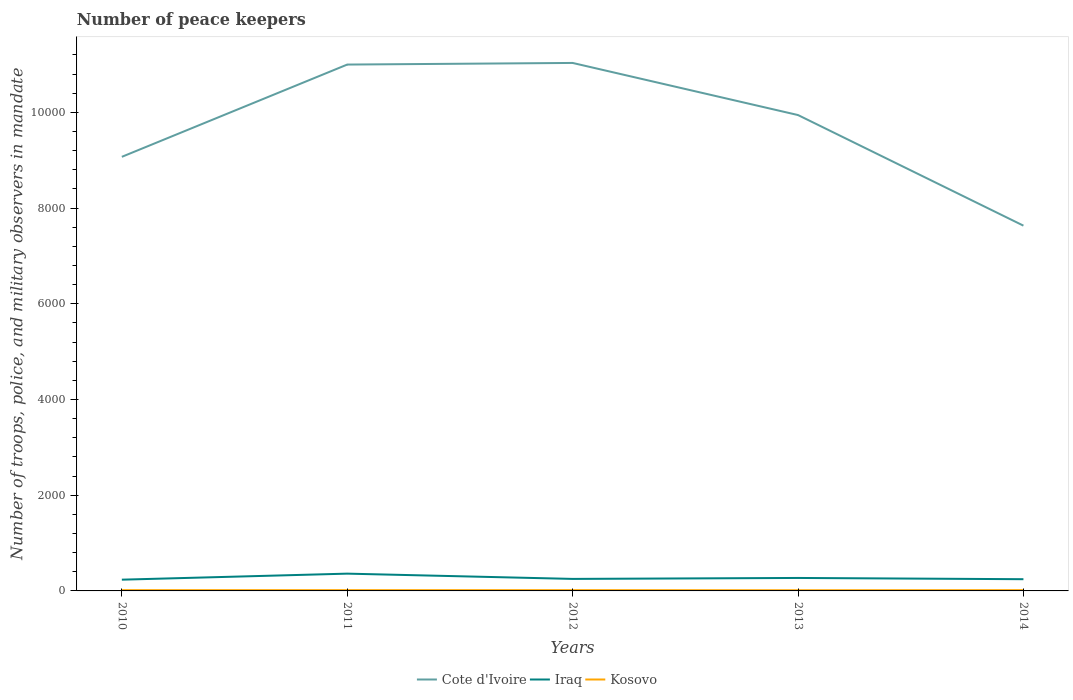How many different coloured lines are there?
Your response must be concise. 3. Across all years, what is the maximum number of peace keepers in in Iraq?
Your answer should be compact. 235. In which year was the number of peace keepers in in Kosovo maximum?
Your response must be concise. 2013. What is the total number of peace keepers in in Iraq in the graph?
Offer a terse response. -20. What is the difference between the highest and the second highest number of peace keepers in in Cote d'Ivoire?
Ensure brevity in your answer.  3400. What is the difference between the highest and the lowest number of peace keepers in in Cote d'Ivoire?
Keep it short and to the point. 3. Is the number of peace keepers in in Iraq strictly greater than the number of peace keepers in in Kosovo over the years?
Provide a short and direct response. No. How many lines are there?
Give a very brief answer. 3. Are the values on the major ticks of Y-axis written in scientific E-notation?
Give a very brief answer. No. Does the graph contain grids?
Keep it short and to the point. No. How are the legend labels stacked?
Provide a short and direct response. Horizontal. What is the title of the graph?
Your answer should be compact. Number of peace keepers. Does "Suriname" appear as one of the legend labels in the graph?
Offer a very short reply. No. What is the label or title of the X-axis?
Your response must be concise. Years. What is the label or title of the Y-axis?
Give a very brief answer. Number of troops, police, and military observers in mandate. What is the Number of troops, police, and military observers in mandate of Cote d'Ivoire in 2010?
Ensure brevity in your answer.  9071. What is the Number of troops, police, and military observers in mandate of Iraq in 2010?
Offer a terse response. 235. What is the Number of troops, police, and military observers in mandate of Kosovo in 2010?
Your answer should be very brief. 16. What is the Number of troops, police, and military observers in mandate in Cote d'Ivoire in 2011?
Your answer should be very brief. 1.10e+04. What is the Number of troops, police, and military observers in mandate of Iraq in 2011?
Your answer should be very brief. 361. What is the Number of troops, police, and military observers in mandate in Cote d'Ivoire in 2012?
Make the answer very short. 1.10e+04. What is the Number of troops, police, and military observers in mandate in Iraq in 2012?
Make the answer very short. 251. What is the Number of troops, police, and military observers in mandate in Cote d'Ivoire in 2013?
Keep it short and to the point. 9944. What is the Number of troops, police, and military observers in mandate in Iraq in 2013?
Give a very brief answer. 271. What is the Number of troops, police, and military observers in mandate of Kosovo in 2013?
Keep it short and to the point. 14. What is the Number of troops, police, and military observers in mandate in Cote d'Ivoire in 2014?
Your response must be concise. 7633. What is the Number of troops, police, and military observers in mandate of Iraq in 2014?
Make the answer very short. 245. What is the Number of troops, police, and military observers in mandate in Kosovo in 2014?
Offer a very short reply. 16. Across all years, what is the maximum Number of troops, police, and military observers in mandate of Cote d'Ivoire?
Your answer should be very brief. 1.10e+04. Across all years, what is the maximum Number of troops, police, and military observers in mandate in Iraq?
Your answer should be compact. 361. Across all years, what is the maximum Number of troops, police, and military observers in mandate of Kosovo?
Give a very brief answer. 16. Across all years, what is the minimum Number of troops, police, and military observers in mandate of Cote d'Ivoire?
Give a very brief answer. 7633. Across all years, what is the minimum Number of troops, police, and military observers in mandate in Iraq?
Give a very brief answer. 235. What is the total Number of troops, police, and military observers in mandate in Cote d'Ivoire in the graph?
Provide a succinct answer. 4.87e+04. What is the total Number of troops, police, and military observers in mandate of Iraq in the graph?
Provide a short and direct response. 1363. What is the difference between the Number of troops, police, and military observers in mandate of Cote d'Ivoire in 2010 and that in 2011?
Offer a terse response. -1928. What is the difference between the Number of troops, police, and military observers in mandate of Iraq in 2010 and that in 2011?
Keep it short and to the point. -126. What is the difference between the Number of troops, police, and military observers in mandate of Kosovo in 2010 and that in 2011?
Your response must be concise. 0. What is the difference between the Number of troops, police, and military observers in mandate of Cote d'Ivoire in 2010 and that in 2012?
Ensure brevity in your answer.  -1962. What is the difference between the Number of troops, police, and military observers in mandate in Kosovo in 2010 and that in 2012?
Offer a terse response. 0. What is the difference between the Number of troops, police, and military observers in mandate in Cote d'Ivoire in 2010 and that in 2013?
Your answer should be very brief. -873. What is the difference between the Number of troops, police, and military observers in mandate of Iraq in 2010 and that in 2013?
Your response must be concise. -36. What is the difference between the Number of troops, police, and military observers in mandate in Kosovo in 2010 and that in 2013?
Offer a very short reply. 2. What is the difference between the Number of troops, police, and military observers in mandate of Cote d'Ivoire in 2010 and that in 2014?
Your answer should be compact. 1438. What is the difference between the Number of troops, police, and military observers in mandate of Cote d'Ivoire in 2011 and that in 2012?
Make the answer very short. -34. What is the difference between the Number of troops, police, and military observers in mandate of Iraq in 2011 and that in 2012?
Provide a succinct answer. 110. What is the difference between the Number of troops, police, and military observers in mandate in Cote d'Ivoire in 2011 and that in 2013?
Provide a succinct answer. 1055. What is the difference between the Number of troops, police, and military observers in mandate of Cote d'Ivoire in 2011 and that in 2014?
Provide a succinct answer. 3366. What is the difference between the Number of troops, police, and military observers in mandate of Iraq in 2011 and that in 2014?
Your answer should be compact. 116. What is the difference between the Number of troops, police, and military observers in mandate of Cote d'Ivoire in 2012 and that in 2013?
Make the answer very short. 1089. What is the difference between the Number of troops, police, and military observers in mandate of Iraq in 2012 and that in 2013?
Give a very brief answer. -20. What is the difference between the Number of troops, police, and military observers in mandate of Cote d'Ivoire in 2012 and that in 2014?
Ensure brevity in your answer.  3400. What is the difference between the Number of troops, police, and military observers in mandate of Cote d'Ivoire in 2013 and that in 2014?
Your answer should be very brief. 2311. What is the difference between the Number of troops, police, and military observers in mandate of Iraq in 2013 and that in 2014?
Your answer should be compact. 26. What is the difference between the Number of troops, police, and military observers in mandate in Kosovo in 2013 and that in 2014?
Offer a very short reply. -2. What is the difference between the Number of troops, police, and military observers in mandate of Cote d'Ivoire in 2010 and the Number of troops, police, and military observers in mandate of Iraq in 2011?
Offer a very short reply. 8710. What is the difference between the Number of troops, police, and military observers in mandate in Cote d'Ivoire in 2010 and the Number of troops, police, and military observers in mandate in Kosovo in 2011?
Your answer should be compact. 9055. What is the difference between the Number of troops, police, and military observers in mandate of Iraq in 2010 and the Number of troops, police, and military observers in mandate of Kosovo in 2011?
Your answer should be compact. 219. What is the difference between the Number of troops, police, and military observers in mandate in Cote d'Ivoire in 2010 and the Number of troops, police, and military observers in mandate in Iraq in 2012?
Give a very brief answer. 8820. What is the difference between the Number of troops, police, and military observers in mandate of Cote d'Ivoire in 2010 and the Number of troops, police, and military observers in mandate of Kosovo in 2012?
Offer a very short reply. 9055. What is the difference between the Number of troops, police, and military observers in mandate in Iraq in 2010 and the Number of troops, police, and military observers in mandate in Kosovo in 2012?
Your response must be concise. 219. What is the difference between the Number of troops, police, and military observers in mandate of Cote d'Ivoire in 2010 and the Number of troops, police, and military observers in mandate of Iraq in 2013?
Offer a very short reply. 8800. What is the difference between the Number of troops, police, and military observers in mandate of Cote d'Ivoire in 2010 and the Number of troops, police, and military observers in mandate of Kosovo in 2013?
Ensure brevity in your answer.  9057. What is the difference between the Number of troops, police, and military observers in mandate in Iraq in 2010 and the Number of troops, police, and military observers in mandate in Kosovo in 2013?
Keep it short and to the point. 221. What is the difference between the Number of troops, police, and military observers in mandate in Cote d'Ivoire in 2010 and the Number of troops, police, and military observers in mandate in Iraq in 2014?
Offer a terse response. 8826. What is the difference between the Number of troops, police, and military observers in mandate of Cote d'Ivoire in 2010 and the Number of troops, police, and military observers in mandate of Kosovo in 2014?
Your answer should be compact. 9055. What is the difference between the Number of troops, police, and military observers in mandate in Iraq in 2010 and the Number of troops, police, and military observers in mandate in Kosovo in 2014?
Offer a very short reply. 219. What is the difference between the Number of troops, police, and military observers in mandate in Cote d'Ivoire in 2011 and the Number of troops, police, and military observers in mandate in Iraq in 2012?
Provide a short and direct response. 1.07e+04. What is the difference between the Number of troops, police, and military observers in mandate of Cote d'Ivoire in 2011 and the Number of troops, police, and military observers in mandate of Kosovo in 2012?
Give a very brief answer. 1.10e+04. What is the difference between the Number of troops, police, and military observers in mandate in Iraq in 2011 and the Number of troops, police, and military observers in mandate in Kosovo in 2012?
Ensure brevity in your answer.  345. What is the difference between the Number of troops, police, and military observers in mandate of Cote d'Ivoire in 2011 and the Number of troops, police, and military observers in mandate of Iraq in 2013?
Offer a terse response. 1.07e+04. What is the difference between the Number of troops, police, and military observers in mandate in Cote d'Ivoire in 2011 and the Number of troops, police, and military observers in mandate in Kosovo in 2013?
Provide a short and direct response. 1.10e+04. What is the difference between the Number of troops, police, and military observers in mandate in Iraq in 2011 and the Number of troops, police, and military observers in mandate in Kosovo in 2013?
Make the answer very short. 347. What is the difference between the Number of troops, police, and military observers in mandate of Cote d'Ivoire in 2011 and the Number of troops, police, and military observers in mandate of Iraq in 2014?
Give a very brief answer. 1.08e+04. What is the difference between the Number of troops, police, and military observers in mandate of Cote d'Ivoire in 2011 and the Number of troops, police, and military observers in mandate of Kosovo in 2014?
Your answer should be compact. 1.10e+04. What is the difference between the Number of troops, police, and military observers in mandate of Iraq in 2011 and the Number of troops, police, and military observers in mandate of Kosovo in 2014?
Provide a succinct answer. 345. What is the difference between the Number of troops, police, and military observers in mandate in Cote d'Ivoire in 2012 and the Number of troops, police, and military observers in mandate in Iraq in 2013?
Keep it short and to the point. 1.08e+04. What is the difference between the Number of troops, police, and military observers in mandate of Cote d'Ivoire in 2012 and the Number of troops, police, and military observers in mandate of Kosovo in 2013?
Your answer should be compact. 1.10e+04. What is the difference between the Number of troops, police, and military observers in mandate in Iraq in 2012 and the Number of troops, police, and military observers in mandate in Kosovo in 2013?
Your answer should be compact. 237. What is the difference between the Number of troops, police, and military observers in mandate of Cote d'Ivoire in 2012 and the Number of troops, police, and military observers in mandate of Iraq in 2014?
Offer a very short reply. 1.08e+04. What is the difference between the Number of troops, police, and military observers in mandate of Cote d'Ivoire in 2012 and the Number of troops, police, and military observers in mandate of Kosovo in 2014?
Give a very brief answer. 1.10e+04. What is the difference between the Number of troops, police, and military observers in mandate in Iraq in 2012 and the Number of troops, police, and military observers in mandate in Kosovo in 2014?
Offer a terse response. 235. What is the difference between the Number of troops, police, and military observers in mandate in Cote d'Ivoire in 2013 and the Number of troops, police, and military observers in mandate in Iraq in 2014?
Keep it short and to the point. 9699. What is the difference between the Number of troops, police, and military observers in mandate of Cote d'Ivoire in 2013 and the Number of troops, police, and military observers in mandate of Kosovo in 2014?
Keep it short and to the point. 9928. What is the difference between the Number of troops, police, and military observers in mandate of Iraq in 2013 and the Number of troops, police, and military observers in mandate of Kosovo in 2014?
Offer a terse response. 255. What is the average Number of troops, police, and military observers in mandate of Cote d'Ivoire per year?
Ensure brevity in your answer.  9736. What is the average Number of troops, police, and military observers in mandate in Iraq per year?
Offer a very short reply. 272.6. In the year 2010, what is the difference between the Number of troops, police, and military observers in mandate of Cote d'Ivoire and Number of troops, police, and military observers in mandate of Iraq?
Your answer should be compact. 8836. In the year 2010, what is the difference between the Number of troops, police, and military observers in mandate in Cote d'Ivoire and Number of troops, police, and military observers in mandate in Kosovo?
Provide a succinct answer. 9055. In the year 2010, what is the difference between the Number of troops, police, and military observers in mandate of Iraq and Number of troops, police, and military observers in mandate of Kosovo?
Provide a short and direct response. 219. In the year 2011, what is the difference between the Number of troops, police, and military observers in mandate of Cote d'Ivoire and Number of troops, police, and military observers in mandate of Iraq?
Provide a short and direct response. 1.06e+04. In the year 2011, what is the difference between the Number of troops, police, and military observers in mandate of Cote d'Ivoire and Number of troops, police, and military observers in mandate of Kosovo?
Your response must be concise. 1.10e+04. In the year 2011, what is the difference between the Number of troops, police, and military observers in mandate of Iraq and Number of troops, police, and military observers in mandate of Kosovo?
Provide a short and direct response. 345. In the year 2012, what is the difference between the Number of troops, police, and military observers in mandate in Cote d'Ivoire and Number of troops, police, and military observers in mandate in Iraq?
Provide a succinct answer. 1.08e+04. In the year 2012, what is the difference between the Number of troops, police, and military observers in mandate of Cote d'Ivoire and Number of troops, police, and military observers in mandate of Kosovo?
Your response must be concise. 1.10e+04. In the year 2012, what is the difference between the Number of troops, police, and military observers in mandate of Iraq and Number of troops, police, and military observers in mandate of Kosovo?
Make the answer very short. 235. In the year 2013, what is the difference between the Number of troops, police, and military observers in mandate of Cote d'Ivoire and Number of troops, police, and military observers in mandate of Iraq?
Provide a short and direct response. 9673. In the year 2013, what is the difference between the Number of troops, police, and military observers in mandate in Cote d'Ivoire and Number of troops, police, and military observers in mandate in Kosovo?
Provide a succinct answer. 9930. In the year 2013, what is the difference between the Number of troops, police, and military observers in mandate of Iraq and Number of troops, police, and military observers in mandate of Kosovo?
Your response must be concise. 257. In the year 2014, what is the difference between the Number of troops, police, and military observers in mandate of Cote d'Ivoire and Number of troops, police, and military observers in mandate of Iraq?
Your response must be concise. 7388. In the year 2014, what is the difference between the Number of troops, police, and military observers in mandate in Cote d'Ivoire and Number of troops, police, and military observers in mandate in Kosovo?
Offer a very short reply. 7617. In the year 2014, what is the difference between the Number of troops, police, and military observers in mandate of Iraq and Number of troops, police, and military observers in mandate of Kosovo?
Provide a short and direct response. 229. What is the ratio of the Number of troops, police, and military observers in mandate of Cote d'Ivoire in 2010 to that in 2011?
Provide a short and direct response. 0.82. What is the ratio of the Number of troops, police, and military observers in mandate of Iraq in 2010 to that in 2011?
Ensure brevity in your answer.  0.65. What is the ratio of the Number of troops, police, and military observers in mandate of Kosovo in 2010 to that in 2011?
Ensure brevity in your answer.  1. What is the ratio of the Number of troops, police, and military observers in mandate in Cote d'Ivoire in 2010 to that in 2012?
Provide a succinct answer. 0.82. What is the ratio of the Number of troops, police, and military observers in mandate in Iraq in 2010 to that in 2012?
Provide a succinct answer. 0.94. What is the ratio of the Number of troops, police, and military observers in mandate of Kosovo in 2010 to that in 2012?
Make the answer very short. 1. What is the ratio of the Number of troops, police, and military observers in mandate of Cote d'Ivoire in 2010 to that in 2013?
Your response must be concise. 0.91. What is the ratio of the Number of troops, police, and military observers in mandate in Iraq in 2010 to that in 2013?
Make the answer very short. 0.87. What is the ratio of the Number of troops, police, and military observers in mandate of Kosovo in 2010 to that in 2013?
Provide a short and direct response. 1.14. What is the ratio of the Number of troops, police, and military observers in mandate of Cote d'Ivoire in 2010 to that in 2014?
Your response must be concise. 1.19. What is the ratio of the Number of troops, police, and military observers in mandate in Iraq in 2010 to that in 2014?
Offer a terse response. 0.96. What is the ratio of the Number of troops, police, and military observers in mandate of Kosovo in 2010 to that in 2014?
Keep it short and to the point. 1. What is the ratio of the Number of troops, police, and military observers in mandate in Cote d'Ivoire in 2011 to that in 2012?
Provide a short and direct response. 1. What is the ratio of the Number of troops, police, and military observers in mandate in Iraq in 2011 to that in 2012?
Provide a succinct answer. 1.44. What is the ratio of the Number of troops, police, and military observers in mandate in Cote d'Ivoire in 2011 to that in 2013?
Your response must be concise. 1.11. What is the ratio of the Number of troops, police, and military observers in mandate in Iraq in 2011 to that in 2013?
Your response must be concise. 1.33. What is the ratio of the Number of troops, police, and military observers in mandate in Kosovo in 2011 to that in 2013?
Ensure brevity in your answer.  1.14. What is the ratio of the Number of troops, police, and military observers in mandate in Cote d'Ivoire in 2011 to that in 2014?
Offer a very short reply. 1.44. What is the ratio of the Number of troops, police, and military observers in mandate of Iraq in 2011 to that in 2014?
Your answer should be compact. 1.47. What is the ratio of the Number of troops, police, and military observers in mandate in Kosovo in 2011 to that in 2014?
Your response must be concise. 1. What is the ratio of the Number of troops, police, and military observers in mandate in Cote d'Ivoire in 2012 to that in 2013?
Keep it short and to the point. 1.11. What is the ratio of the Number of troops, police, and military observers in mandate of Iraq in 2012 to that in 2013?
Ensure brevity in your answer.  0.93. What is the ratio of the Number of troops, police, and military observers in mandate in Kosovo in 2012 to that in 2013?
Your answer should be very brief. 1.14. What is the ratio of the Number of troops, police, and military observers in mandate in Cote d'Ivoire in 2012 to that in 2014?
Provide a succinct answer. 1.45. What is the ratio of the Number of troops, police, and military observers in mandate of Iraq in 2012 to that in 2014?
Make the answer very short. 1.02. What is the ratio of the Number of troops, police, and military observers in mandate of Cote d'Ivoire in 2013 to that in 2014?
Provide a succinct answer. 1.3. What is the ratio of the Number of troops, police, and military observers in mandate in Iraq in 2013 to that in 2014?
Your answer should be compact. 1.11. What is the difference between the highest and the second highest Number of troops, police, and military observers in mandate of Iraq?
Give a very brief answer. 90. What is the difference between the highest and the second highest Number of troops, police, and military observers in mandate of Kosovo?
Offer a very short reply. 0. What is the difference between the highest and the lowest Number of troops, police, and military observers in mandate of Cote d'Ivoire?
Give a very brief answer. 3400. What is the difference between the highest and the lowest Number of troops, police, and military observers in mandate in Iraq?
Your response must be concise. 126. 